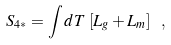<formula> <loc_0><loc_0><loc_500><loc_500>S _ { 4 * } = \int d T \, \left [ L _ { g } + L _ { m } \right ] \ ,</formula> 